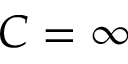Convert formula to latex. <formula><loc_0><loc_0><loc_500><loc_500>C = \infty</formula> 